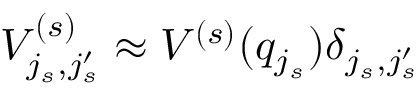<formula> <loc_0><loc_0><loc_500><loc_500>V _ { j _ { s } , j _ { s } ^ { \prime } } ^ { ( s ) } \approx V ^ { ( s ) } ( q _ { j _ { s } } ) \delta _ { j _ { s } , j _ { s } ^ { \prime } }</formula> 